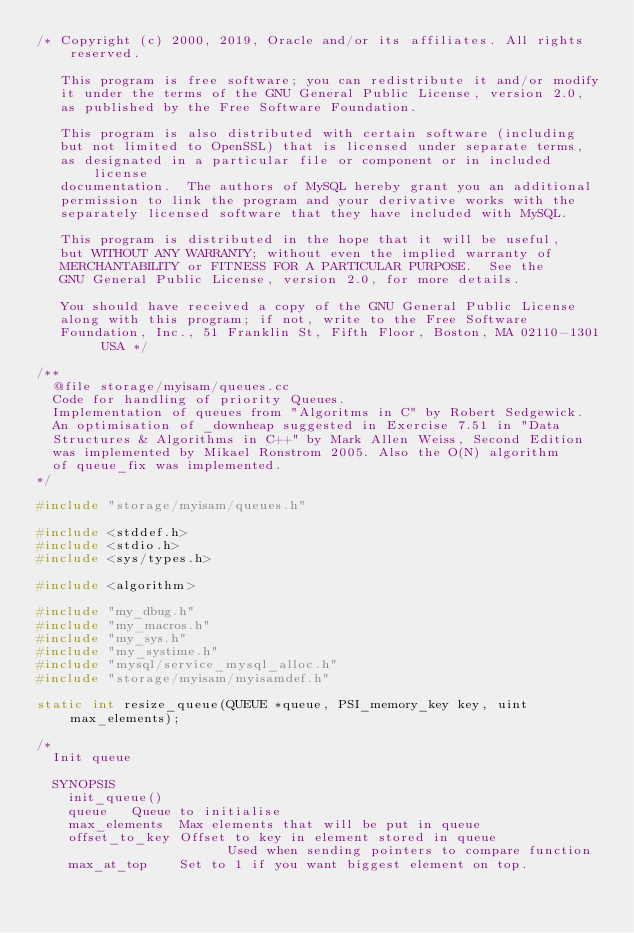Convert code to text. <code><loc_0><loc_0><loc_500><loc_500><_C++_>/* Copyright (c) 2000, 2019, Oracle and/or its affiliates. All rights reserved.

   This program is free software; you can redistribute it and/or modify
   it under the terms of the GNU General Public License, version 2.0,
   as published by the Free Software Foundation.

   This program is also distributed with certain software (including
   but not limited to OpenSSL) that is licensed under separate terms,
   as designated in a particular file or component or in included license
   documentation.  The authors of MySQL hereby grant you an additional
   permission to link the program and your derivative works with the
   separately licensed software that they have included with MySQL.

   This program is distributed in the hope that it will be useful,
   but WITHOUT ANY WARRANTY; without even the implied warranty of
   MERCHANTABILITY or FITNESS FOR A PARTICULAR PURPOSE.  See the
   GNU General Public License, version 2.0, for more details.

   You should have received a copy of the GNU General Public License
   along with this program; if not, write to the Free Software
   Foundation, Inc., 51 Franklin St, Fifth Floor, Boston, MA 02110-1301  USA */

/**
  @file storage/myisam/queues.cc
  Code for handling of priority Queues.
  Implementation of queues from "Algoritms in C" by Robert Sedgewick.
  An optimisation of _downheap suggested in Exercise 7.51 in "Data
  Structures & Algorithms in C++" by Mark Allen Weiss, Second Edition
  was implemented by Mikael Ronstrom 2005. Also the O(N) algorithm
  of queue_fix was implemented.
*/

#include "storage/myisam/queues.h"

#include <stddef.h>
#include <stdio.h>
#include <sys/types.h>

#include <algorithm>

#include "my_dbug.h"
#include "my_macros.h"
#include "my_sys.h"
#include "my_systime.h"
#include "mysql/service_mysql_alloc.h"
#include "storage/myisam/myisamdef.h"

static int resize_queue(QUEUE *queue, PSI_memory_key key, uint max_elements);

/*
  Init queue

  SYNOPSIS
    init_queue()
    queue		Queue to initialise
    max_elements	Max elements that will be put in queue
    offset_to_key	Offset to key in element stored in queue
                        Used when sending pointers to compare function
    max_at_top		Set to 1 if you want biggest element on top.</code> 